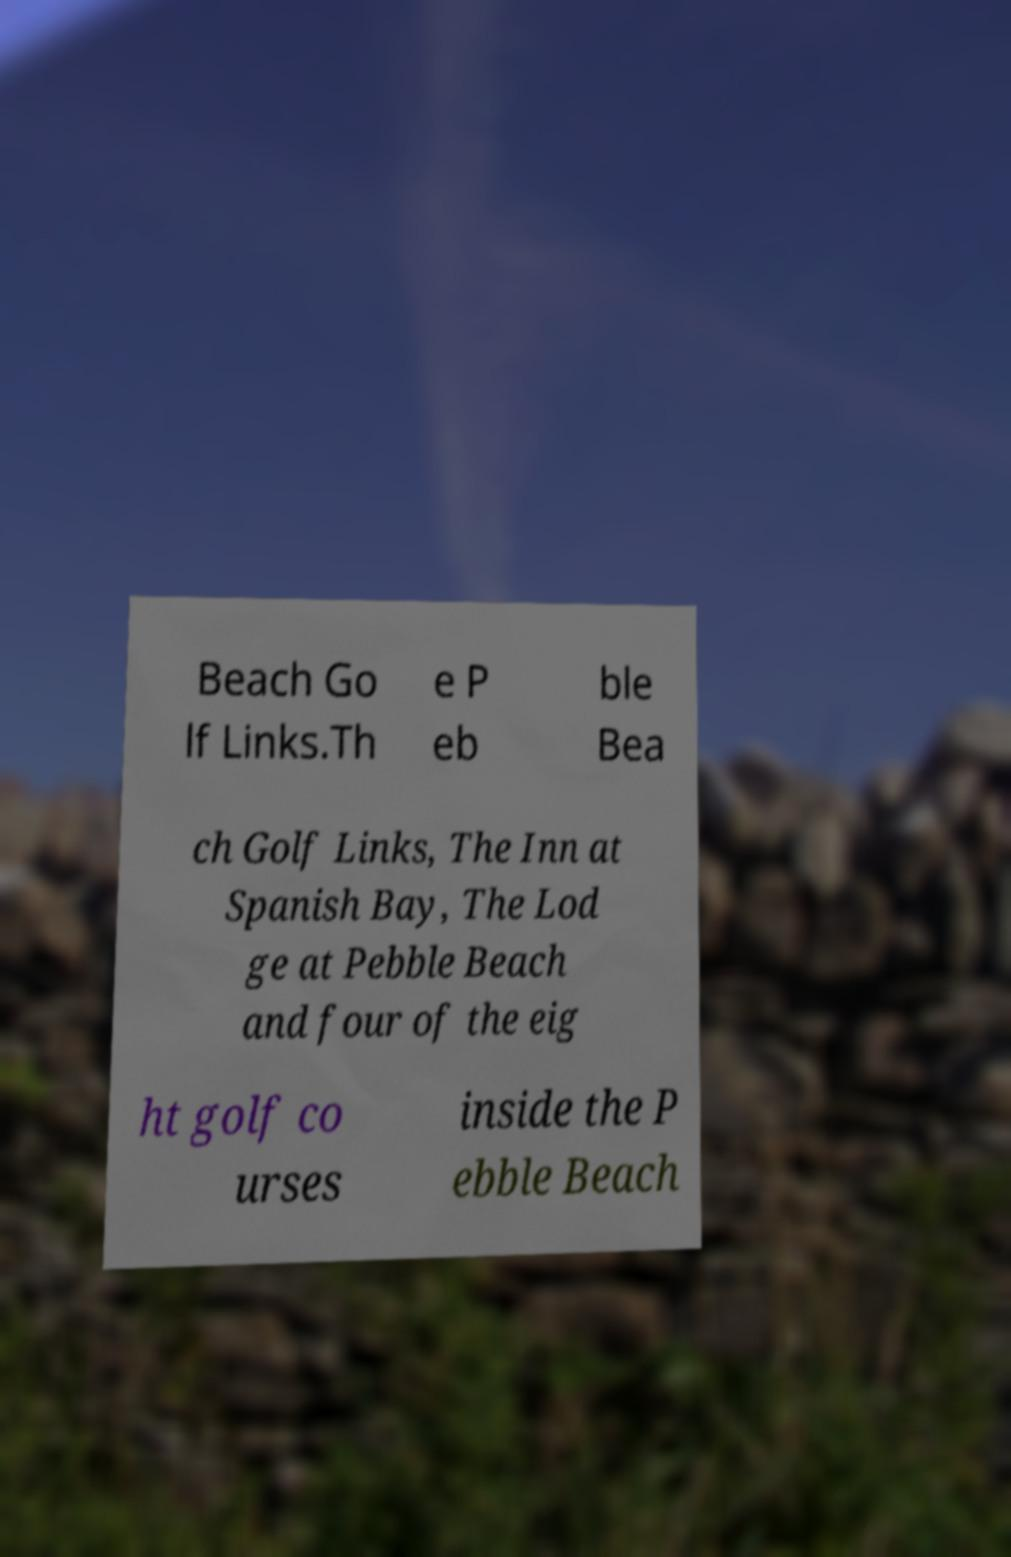For documentation purposes, I need the text within this image transcribed. Could you provide that? Beach Go lf Links.Th e P eb ble Bea ch Golf Links, The Inn at Spanish Bay, The Lod ge at Pebble Beach and four of the eig ht golf co urses inside the P ebble Beach 